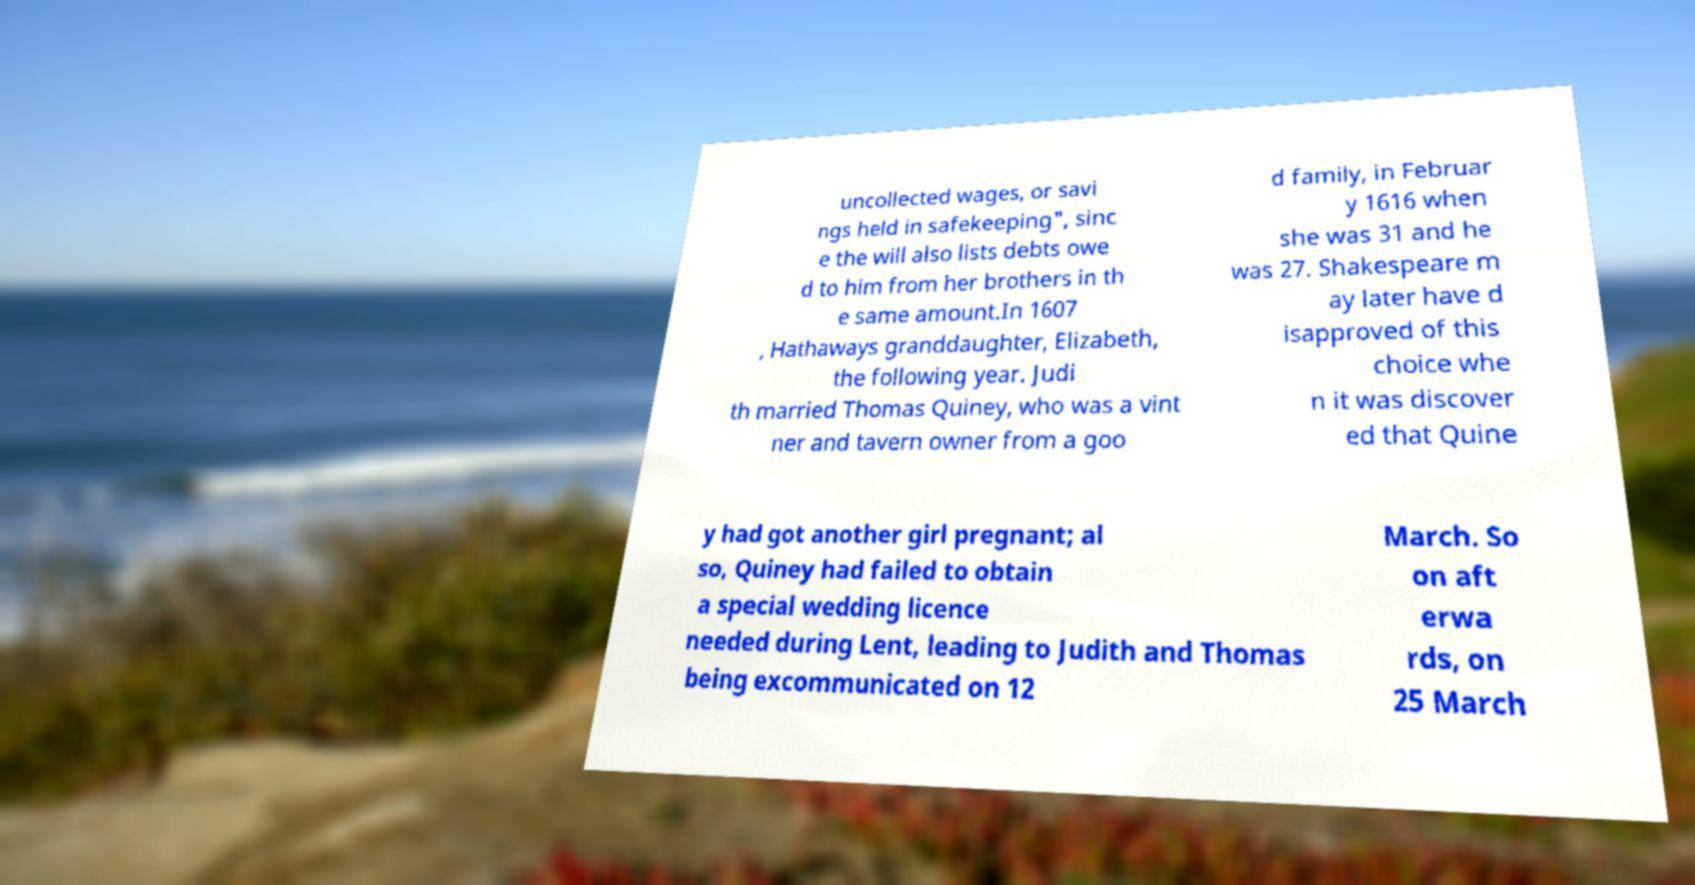Can you read and provide the text displayed in the image?This photo seems to have some interesting text. Can you extract and type it out for me? uncollected wages, or savi ngs held in safekeeping", sinc e the will also lists debts owe d to him from her brothers in th e same amount.In 1607 , Hathaways granddaughter, Elizabeth, the following year. Judi th married Thomas Quiney, who was a vint ner and tavern owner from a goo d family, in Februar y 1616 when she was 31 and he was 27. Shakespeare m ay later have d isapproved of this choice whe n it was discover ed that Quine y had got another girl pregnant; al so, Quiney had failed to obtain a special wedding licence needed during Lent, leading to Judith and Thomas being excommunicated on 12 March. So on aft erwa rds, on 25 March 